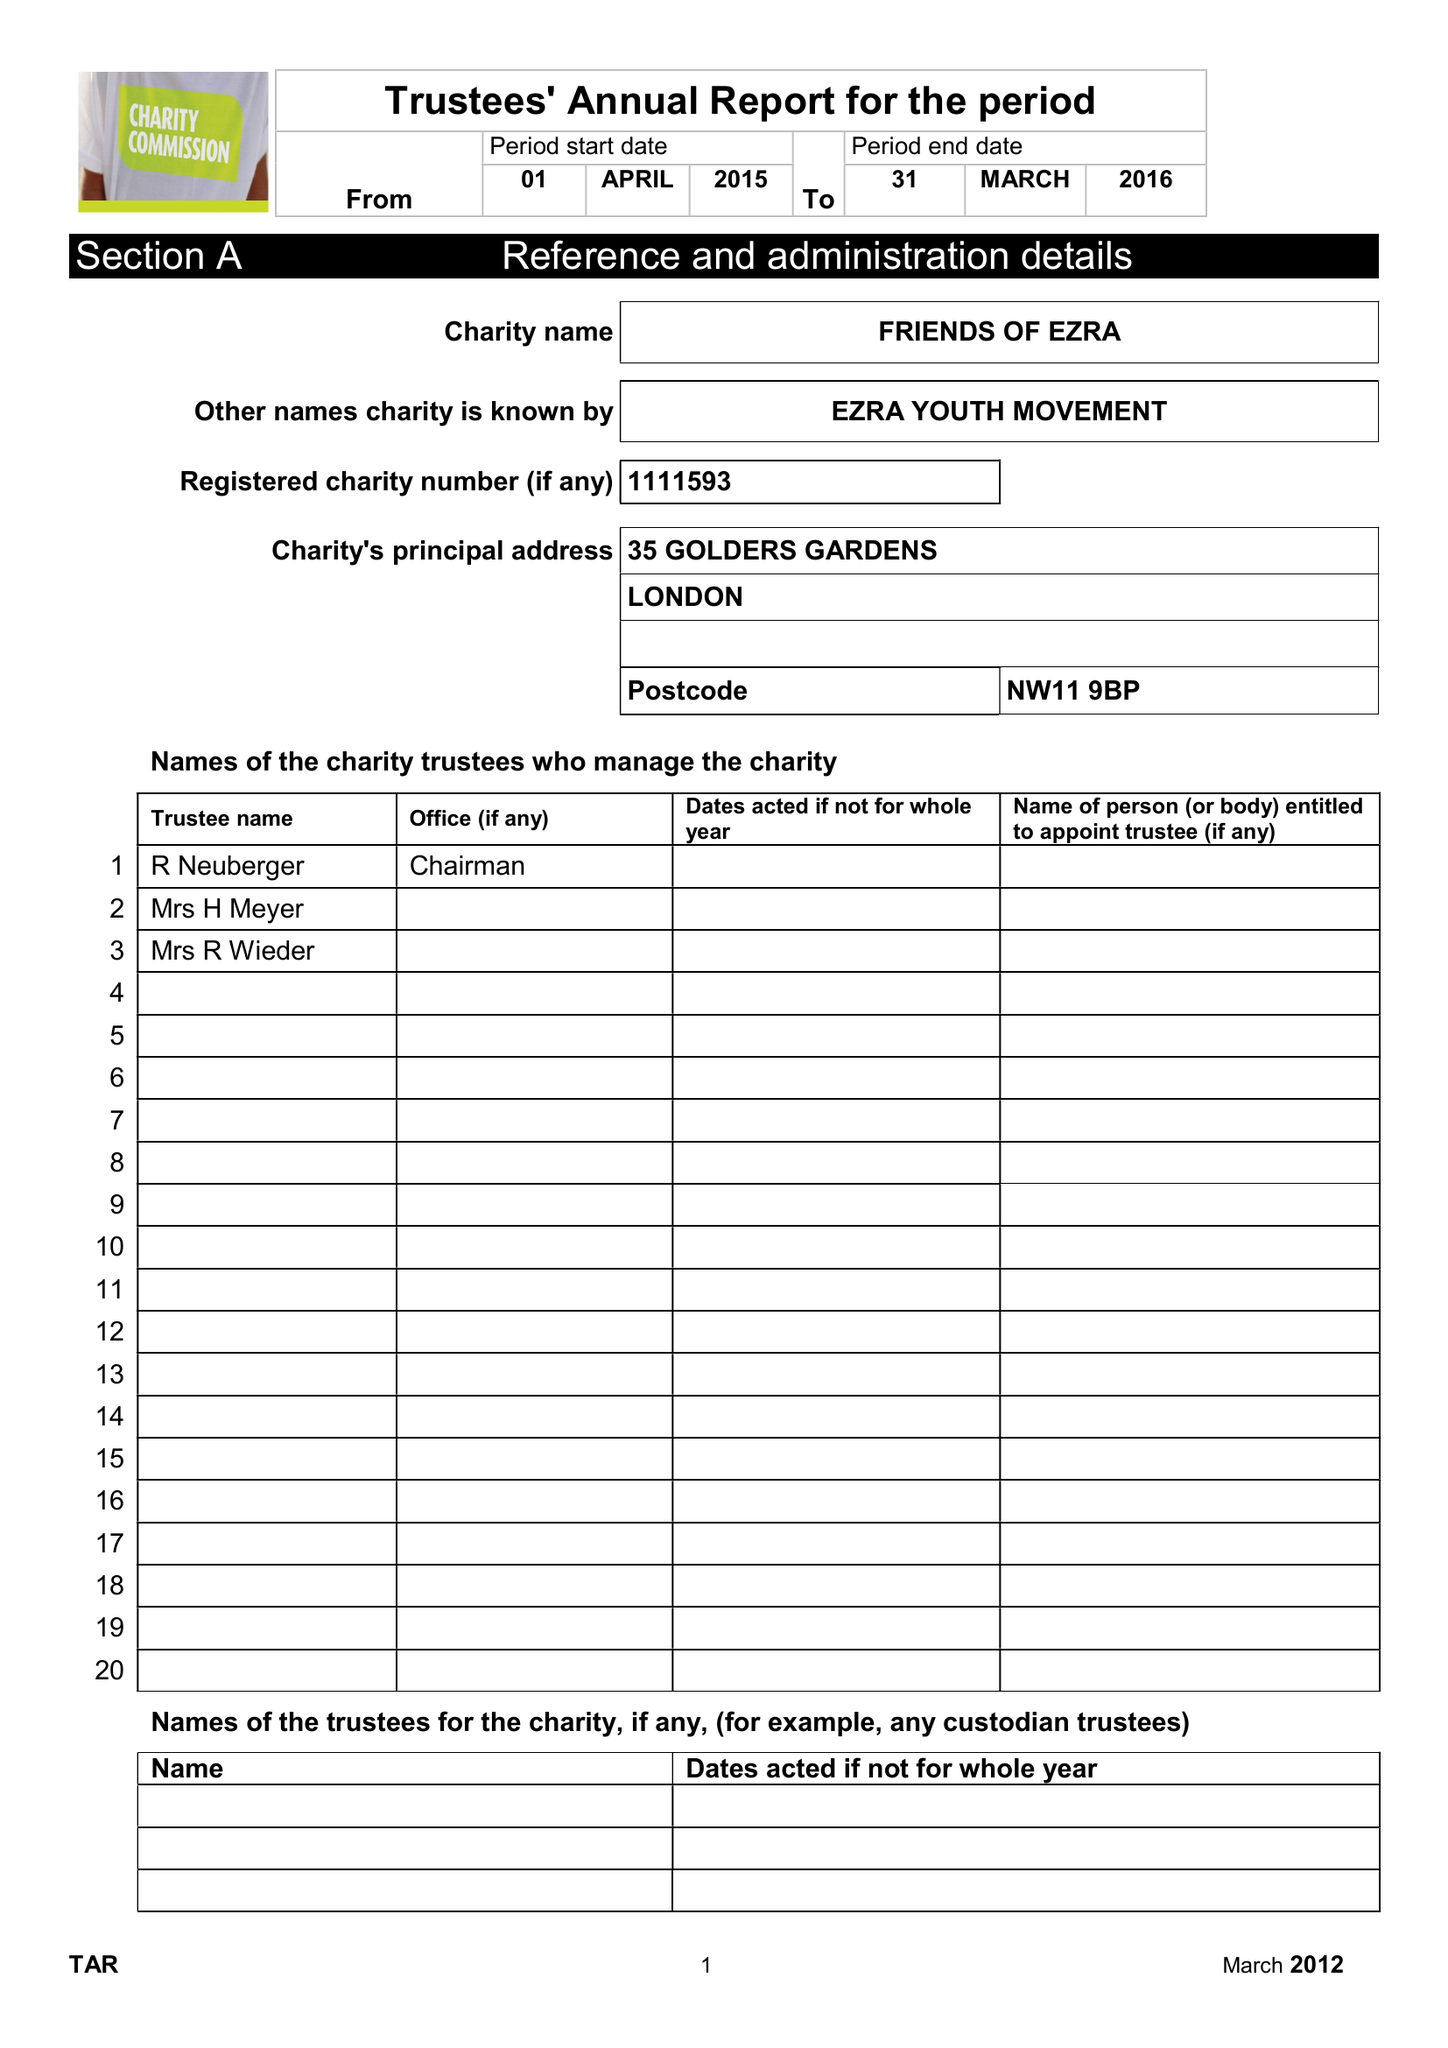What is the value for the spending_annually_in_british_pounds?
Answer the question using a single word or phrase. 281316.00 